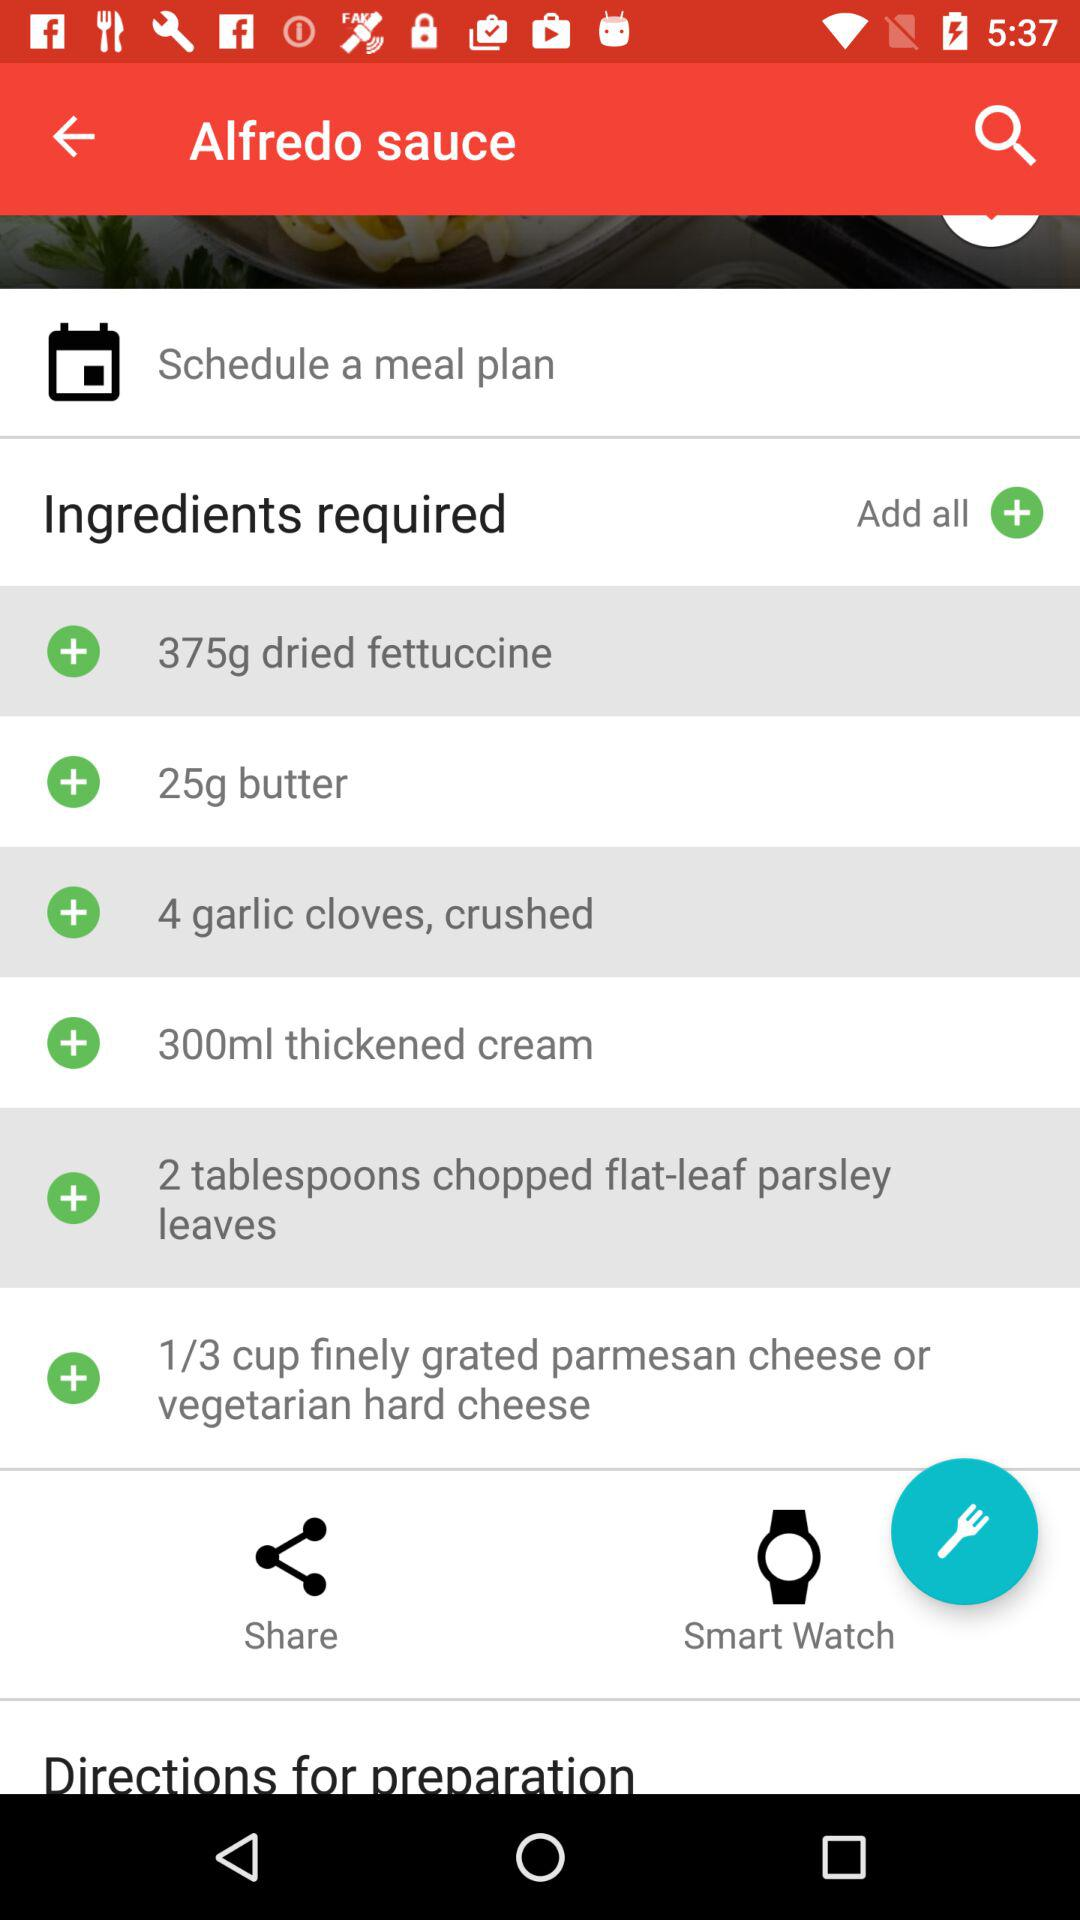What are the ingredients required to prepare the Alfredo sauce? The required items in ingredients list are "375g dried fettuccine", "25g butter", "4 garlic cloves, crushed", "300ml thickened cream", "2 tablespoons chopped flat-leaf parsley leaves" and "1/3 cup finely grated parmesan cheese or vegetarian hard cheese". 